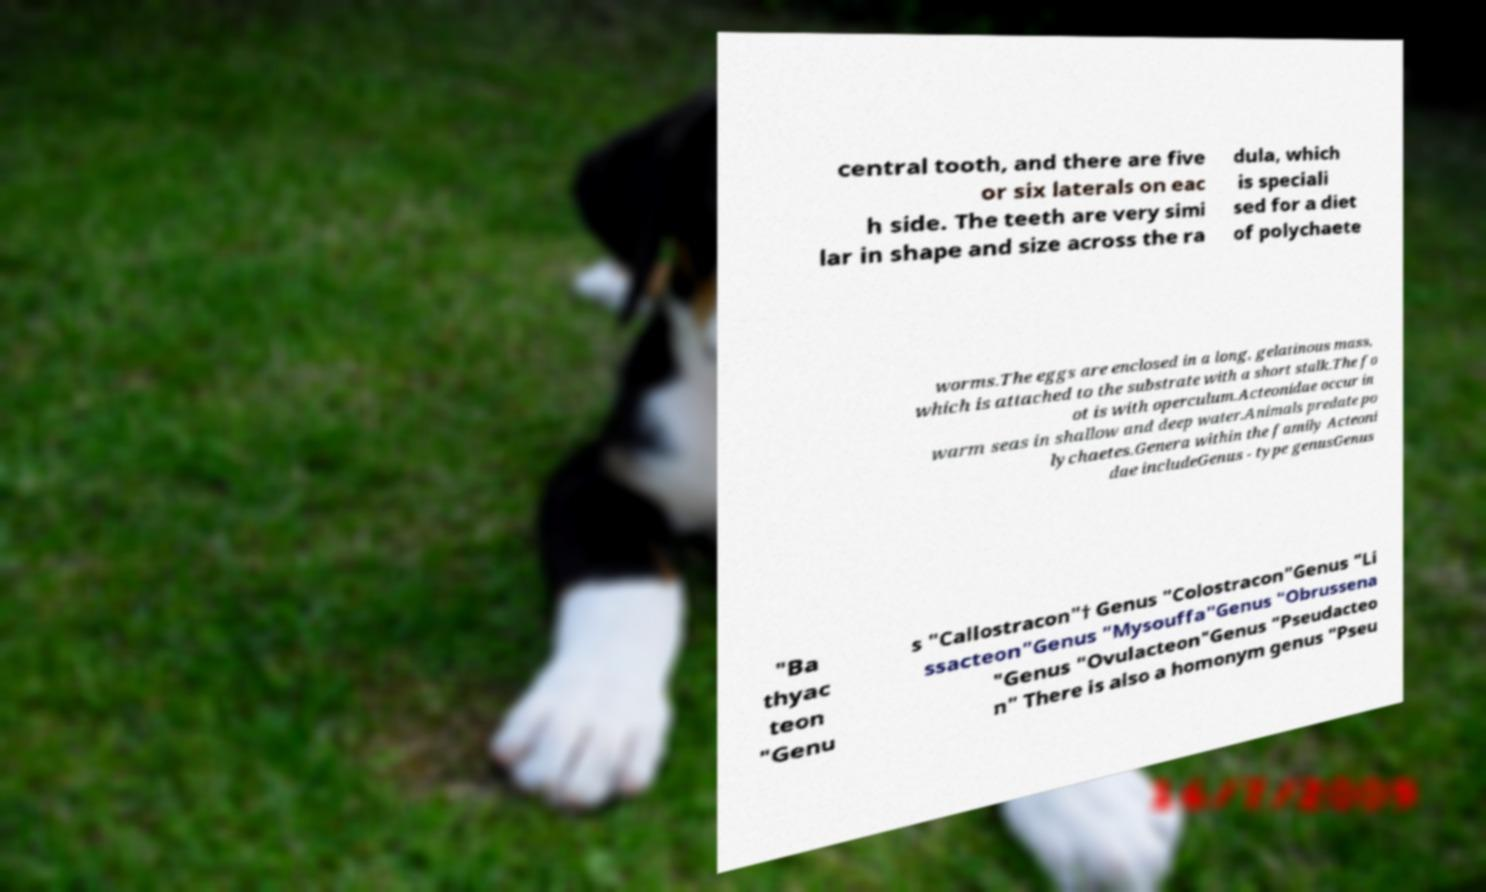I need the written content from this picture converted into text. Can you do that? central tooth, and there are five or six laterals on eac h side. The teeth are very simi lar in shape and size across the ra dula, which is speciali sed for a diet of polychaete worms.The eggs are enclosed in a long, gelatinous mass, which is attached to the substrate with a short stalk.The fo ot is with operculum.Acteonidae occur in warm seas in shallow and deep water.Animals predate po lychaetes.Genera within the family Acteoni dae includeGenus - type genusGenus "Ba thyac teon "Genu s "Callostracon"† Genus "Colostracon"Genus "Li ssacteon"Genus "Mysouffa"Genus "Obrussena "Genus "Ovulacteon"Genus "Pseudacteo n" There is also a homonym genus "Pseu 